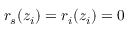<formula> <loc_0><loc_0><loc_500><loc_500>r _ { s } ( z _ { i } ) = r _ { i } ( z _ { i } ) = 0</formula> 